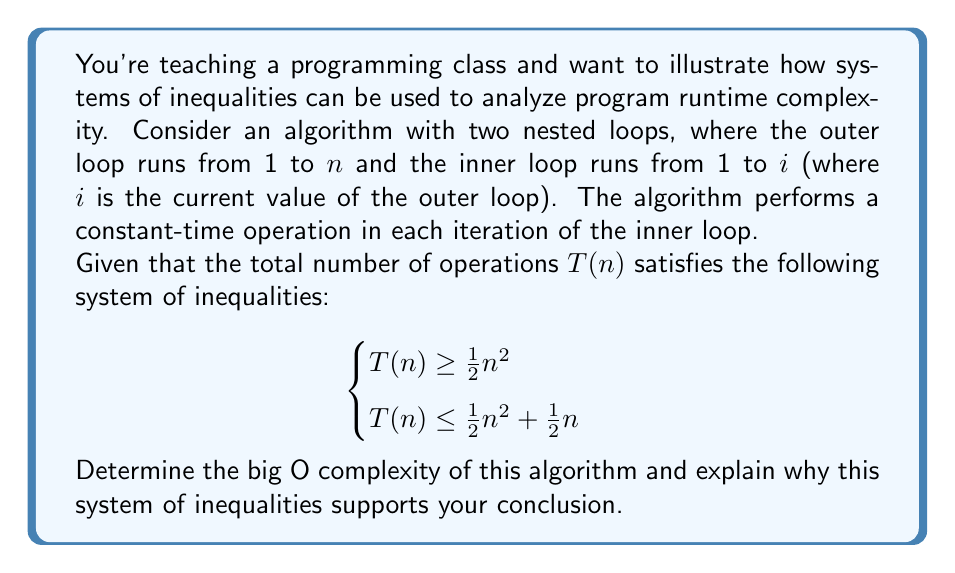Can you answer this question? Let's approach this step-by-step:

1) First, let's understand what the inequalities mean:
   - $T(n) \geq \frac{1}{2}n^2$ gives us a lower bound on the number of operations.
   - $T(n) \leq \frac{1}{2}n^2 + \frac{1}{2}n$ gives us an upper bound.

2) In big O notation, we're interested in the asymptotic upper bound. However, the tightness of both bounds is also important for precise analysis.

3) Let's look at the upper bound: $T(n) \leq \frac{1}{2}n^2 + \frac{1}{2}n$
   - The dominant term here is $\frac{1}{2}n^2$, as $n$ grows large.
   - $\frac{1}{2}n$ becomes insignificant compared to $\frac{1}{2}n^2$ for large $n$.

4) Now, let's consider the lower bound: $T(n) \geq \frac{1}{2}n^2$
   - This tells us that the algorithm performs at least $\frac{1}{2}n^2$ operations.

5) Combining these observations:
   - The algorithm performs at least $\frac{1}{2}n^2$ operations.
   - It performs at most $\frac{1}{2}n^2 + \frac{1}{2}n$ operations.

6) In big O notation, we drop constant factors and lower-order terms. Both bounds are essentially $n^2$, ignoring constants and lower-order terms.

7) Therefore, we can conclude that $T(n) = O(n^2)$.

8) This system of inequalities supports this conclusion because:
   - It provides both a lower and upper bound that are quadratic in $n$.
   - The bounds are tight (differ only by a linear term), confirming that $O(n^2)$ is the most precise big O description for this algorithm.
Answer: $O(n^2)$ 